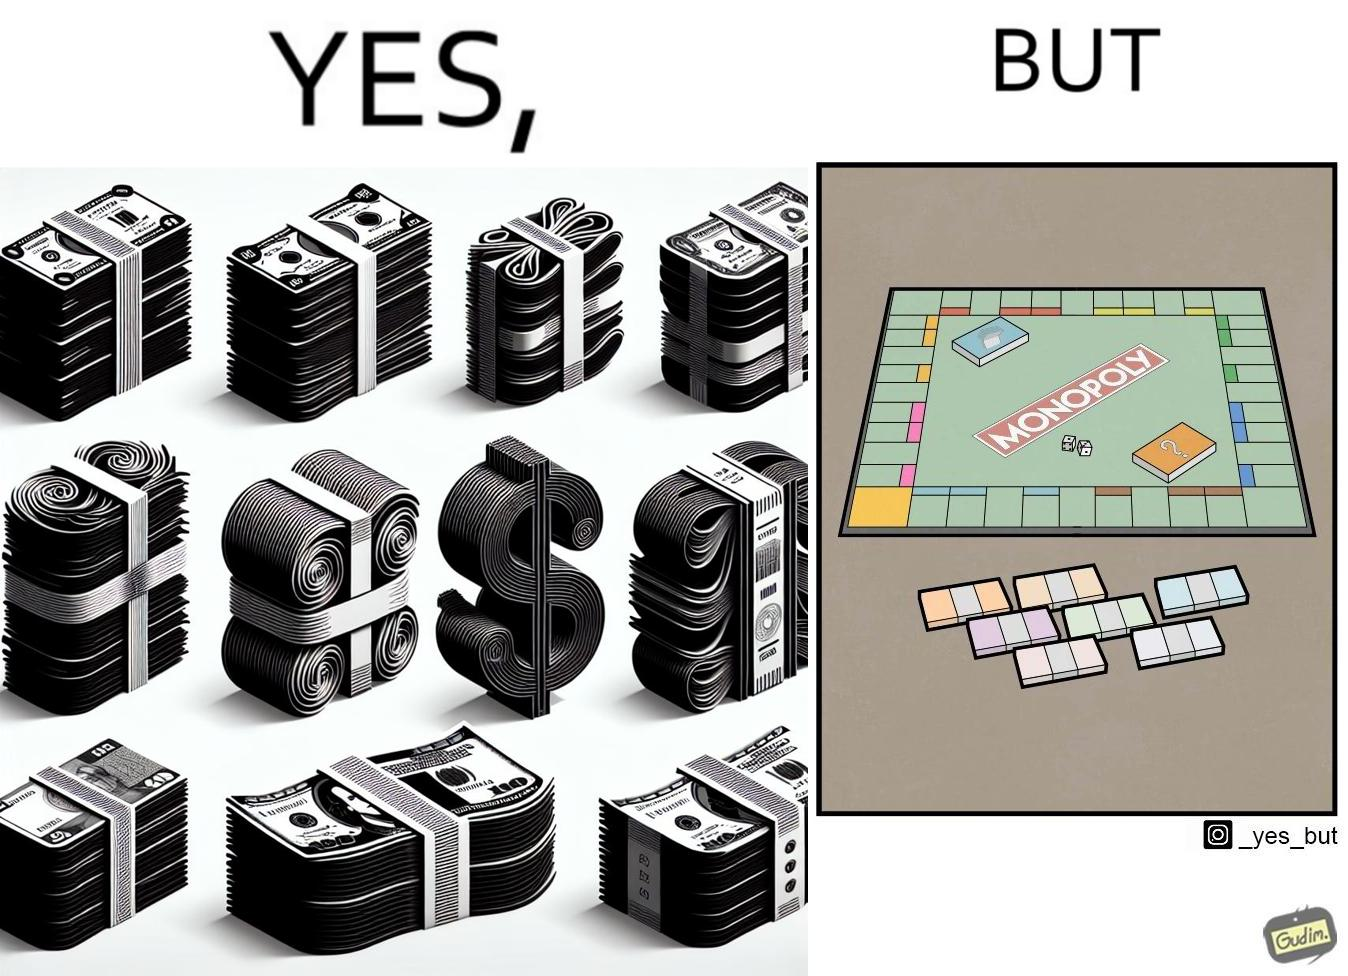What makes this image funny or satirical? The image is ironic, because there are many different color currency notes' bundles but they are just as a currency in the game of monopoly and they have no real value 